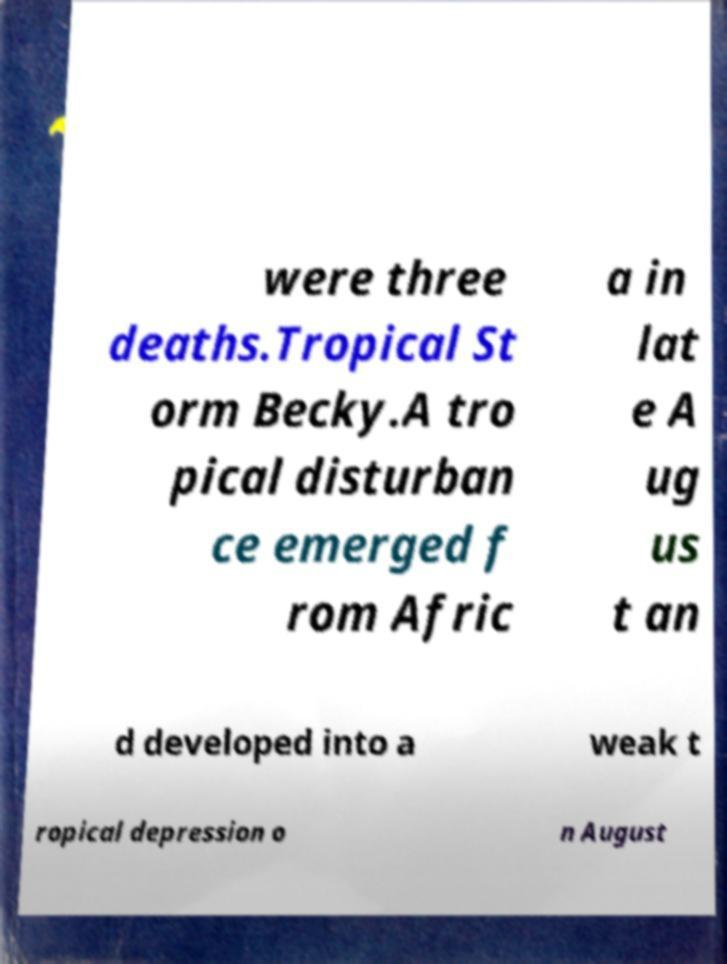There's text embedded in this image that I need extracted. Can you transcribe it verbatim? were three deaths.Tropical St orm Becky.A tro pical disturban ce emerged f rom Afric a in lat e A ug us t an d developed into a weak t ropical depression o n August 